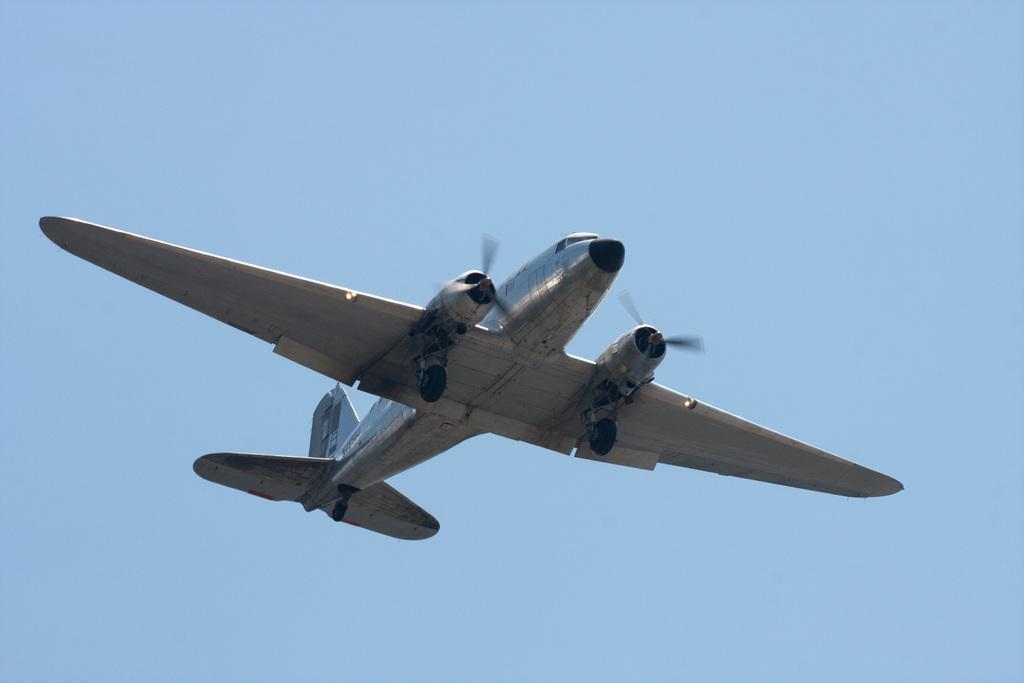What is the main subject of the image? The main subject of the image is an airplane. What is the airplane doing in the image? The airplane is flying in the air. What can be seen above the airplane in the image? The sky is visible above the airplane. What type of whistle can be heard coming from the airplane in the image? There is no whistle present in the image, and therefore no sound can be heard. 